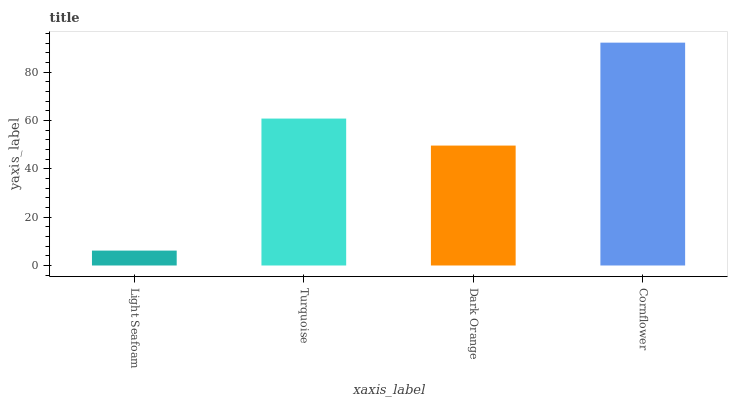Is Light Seafoam the minimum?
Answer yes or no. Yes. Is Cornflower the maximum?
Answer yes or no. Yes. Is Turquoise the minimum?
Answer yes or no. No. Is Turquoise the maximum?
Answer yes or no. No. Is Turquoise greater than Light Seafoam?
Answer yes or no. Yes. Is Light Seafoam less than Turquoise?
Answer yes or no. Yes. Is Light Seafoam greater than Turquoise?
Answer yes or no. No. Is Turquoise less than Light Seafoam?
Answer yes or no. No. Is Turquoise the high median?
Answer yes or no. Yes. Is Dark Orange the low median?
Answer yes or no. Yes. Is Dark Orange the high median?
Answer yes or no. No. Is Light Seafoam the low median?
Answer yes or no. No. 